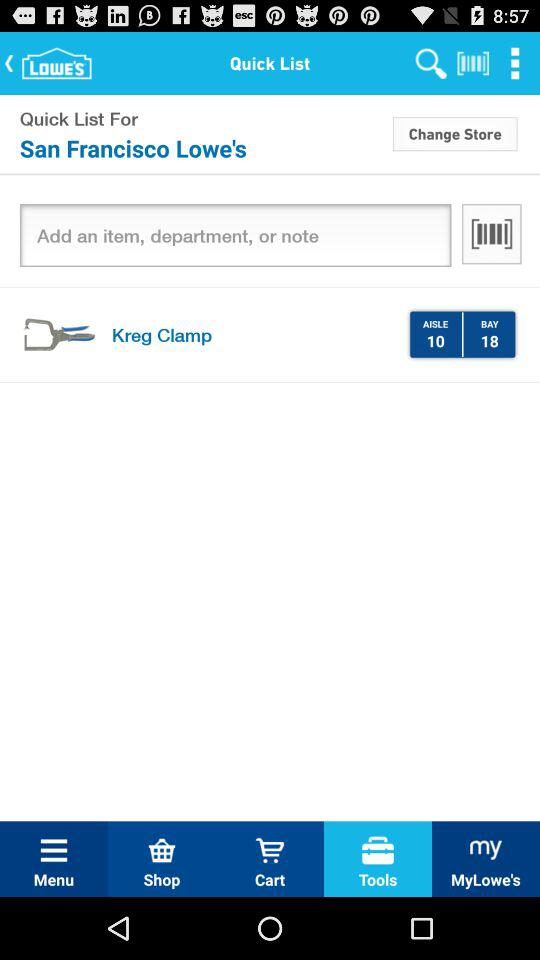Which tab is selected? The selected tab is "Tools". 